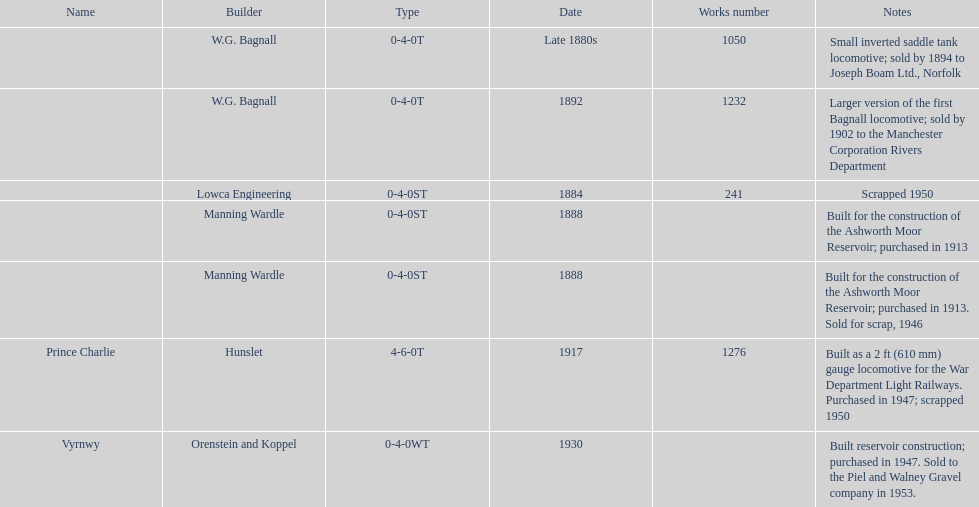How many locomotives were built after 1900? 2. 